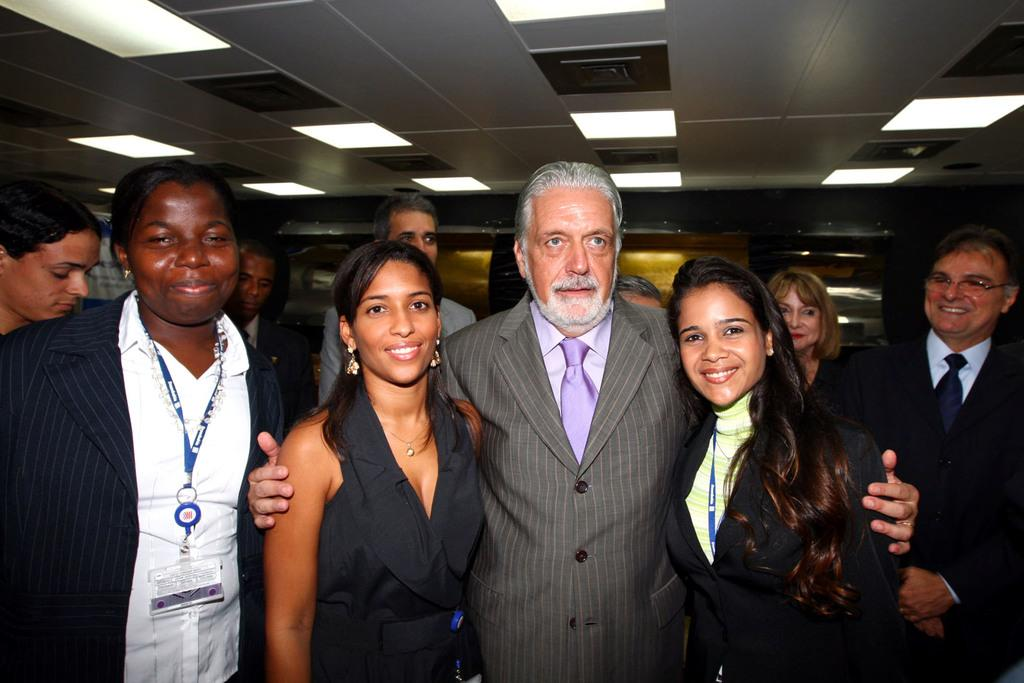How many people are visible in the front of the image? There are four people standing in front of the image. What is the facial expression of the people in the front? The four people are smiling. Are there any other people visible in the image? Yes, there are other people behind them. What type of lighting is present in the image? There are lamps on the ceiling. Can you tell me how many times the people in the image have pulled a spade today? There is no information about spades or any pulling activity in the image, so it cannot be determined. 